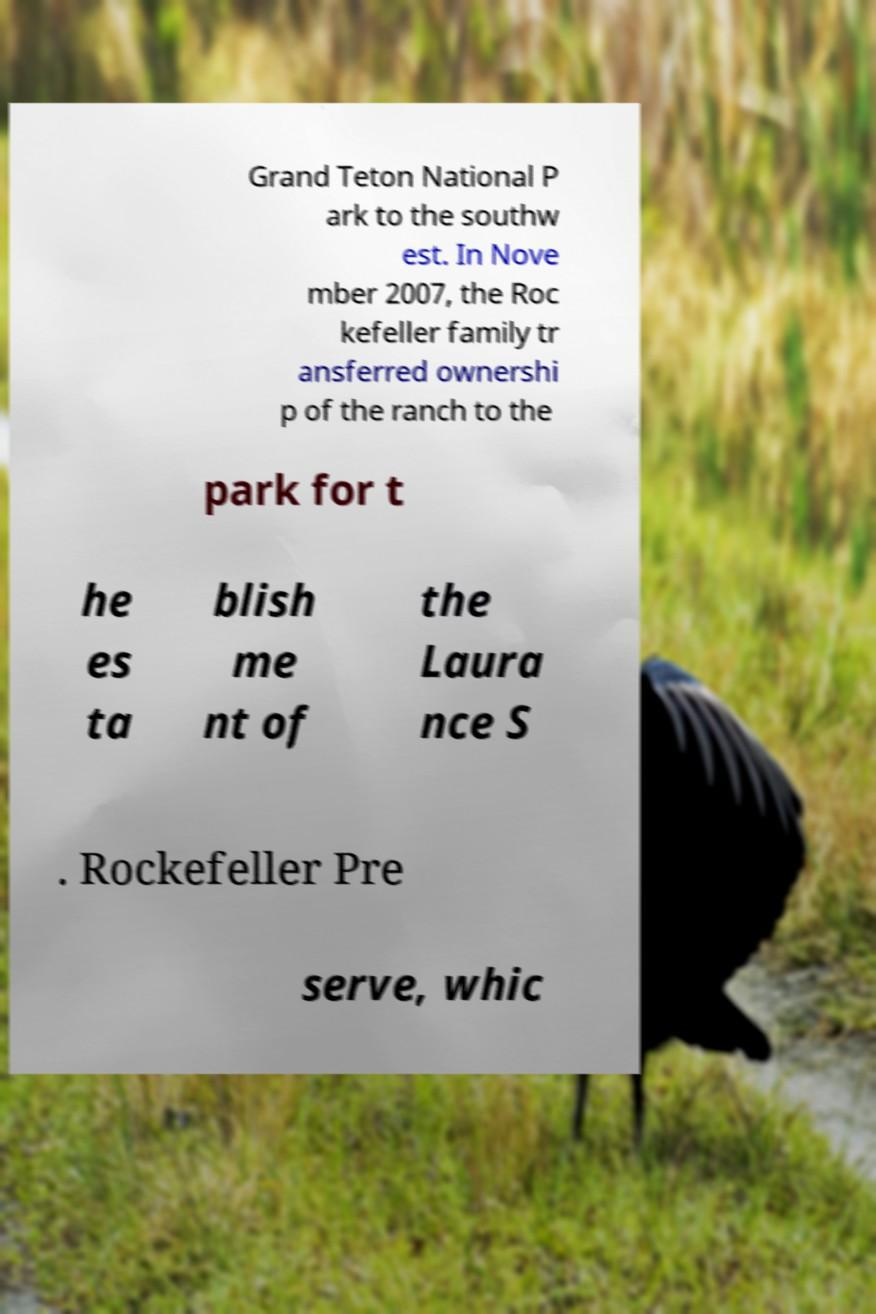Can you read and provide the text displayed in the image?This photo seems to have some interesting text. Can you extract and type it out for me? Grand Teton National P ark to the southw est. In Nove mber 2007, the Roc kefeller family tr ansferred ownershi p of the ranch to the park for t he es ta blish me nt of the Laura nce S . Rockefeller Pre serve, whic 